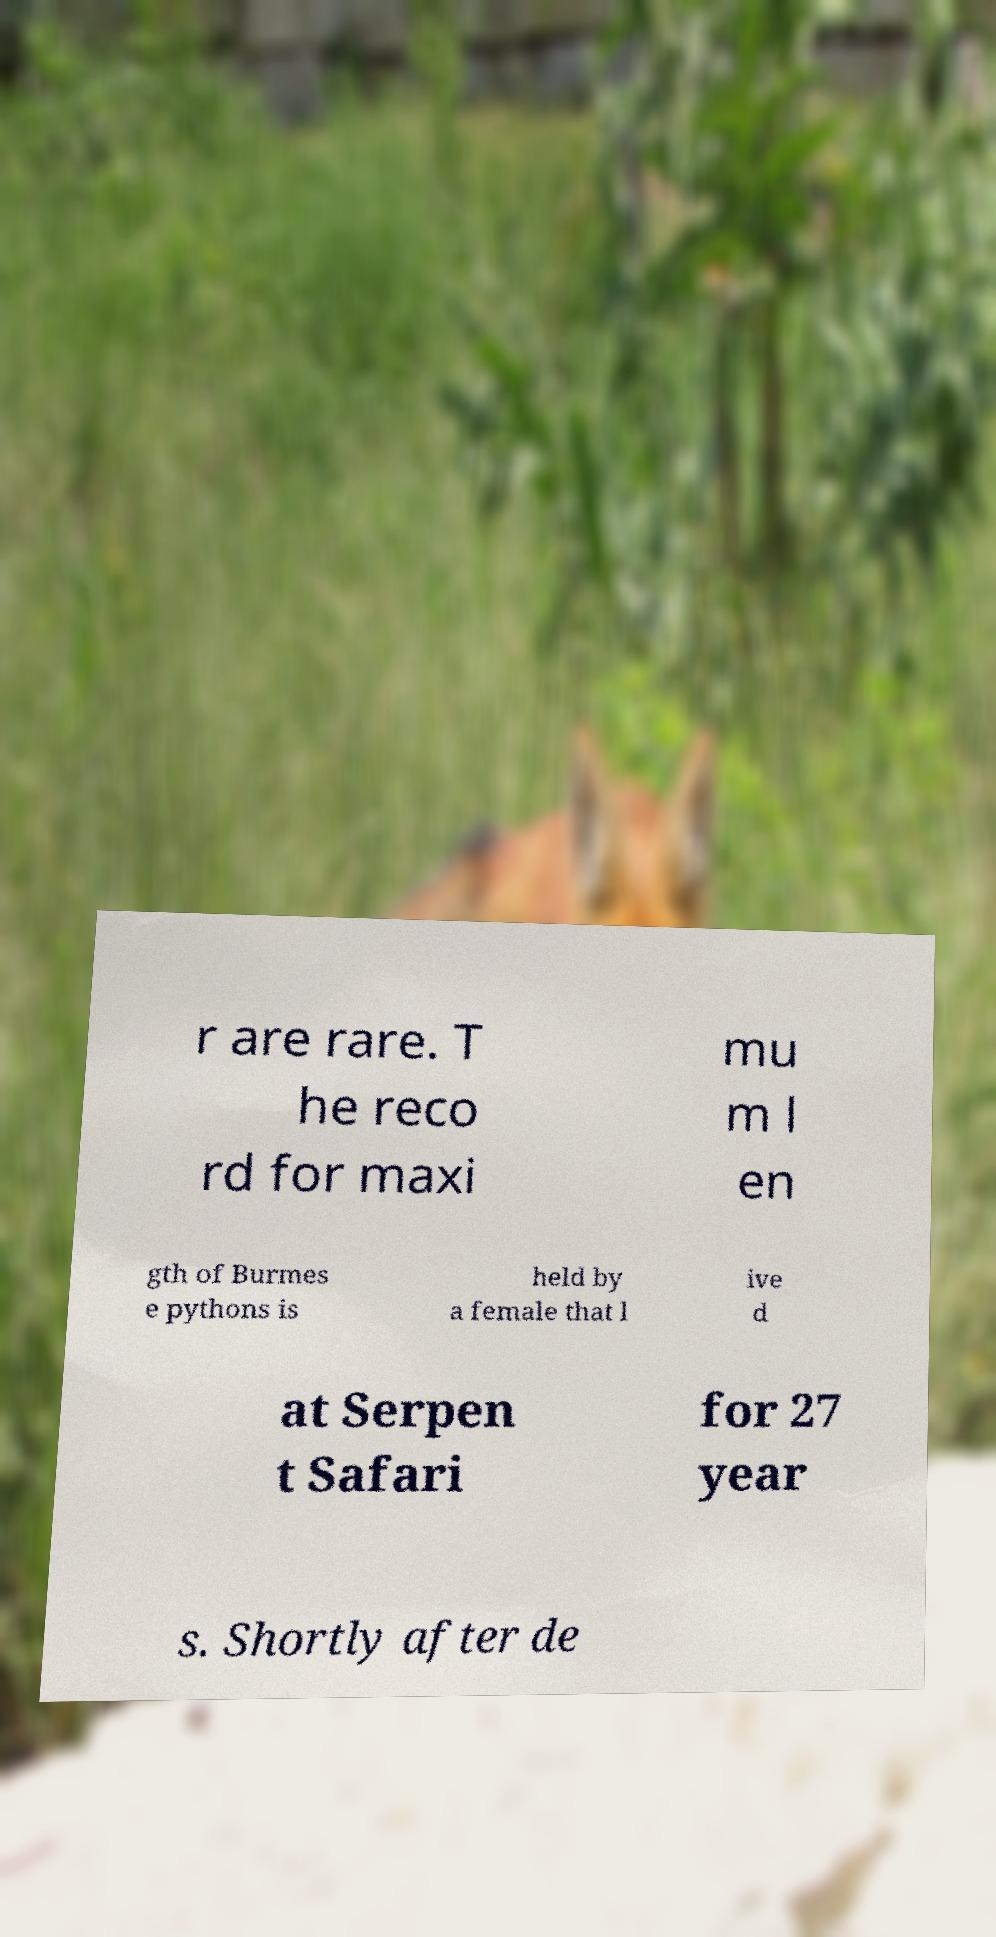Can you read and provide the text displayed in the image?This photo seems to have some interesting text. Can you extract and type it out for me? r are rare. T he reco rd for maxi mu m l en gth of Burmes e pythons is held by a female that l ive d at Serpen t Safari for 27 year s. Shortly after de 